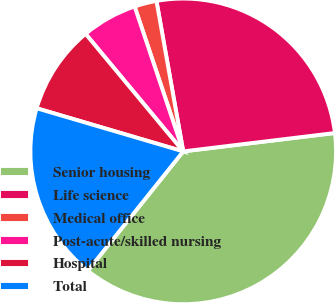Convert chart to OTSL. <chart><loc_0><loc_0><loc_500><loc_500><pie_chart><fcel>Senior housing<fcel>Life science<fcel>Medical office<fcel>Post-acute/skilled nursing<fcel>Hospital<fcel>Total<nl><fcel>37.65%<fcel>25.88%<fcel>2.35%<fcel>5.88%<fcel>9.41%<fcel>18.82%<nl></chart> 